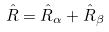<formula> <loc_0><loc_0><loc_500><loc_500>\hat { R } = \hat { R } _ { \alpha } + \hat { R } _ { \beta }</formula> 